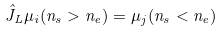<formula> <loc_0><loc_0><loc_500><loc_500>\hat { J } _ { L } \mu _ { i } ( n _ { s } > n _ { e } ) = \mu _ { j } ( n _ { s } < n _ { e } )</formula> 